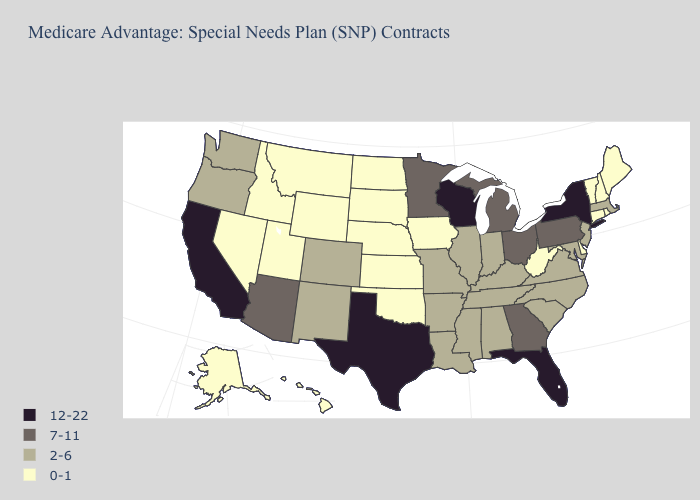Does Idaho have the lowest value in the West?
Answer briefly. Yes. Which states hav the highest value in the MidWest?
Give a very brief answer. Wisconsin. What is the lowest value in states that border Connecticut?
Write a very short answer. 0-1. What is the value of West Virginia?
Quick response, please. 0-1. What is the lowest value in states that border Washington?
Be succinct. 0-1. Does North Dakota have the lowest value in the USA?
Answer briefly. Yes. Which states hav the highest value in the Northeast?
Give a very brief answer. New York. What is the value of Kansas?
Write a very short answer. 0-1. What is the value of Massachusetts?
Short answer required. 2-6. Does Oklahoma have the lowest value in the South?
Give a very brief answer. Yes. Does Texas have the highest value in the USA?
Concise answer only. Yes. What is the highest value in the South ?
Be succinct. 12-22. Does West Virginia have a lower value than Maine?
Concise answer only. No. Name the states that have a value in the range 12-22?
Give a very brief answer. California, Florida, New York, Texas, Wisconsin. How many symbols are there in the legend?
Be succinct. 4. 